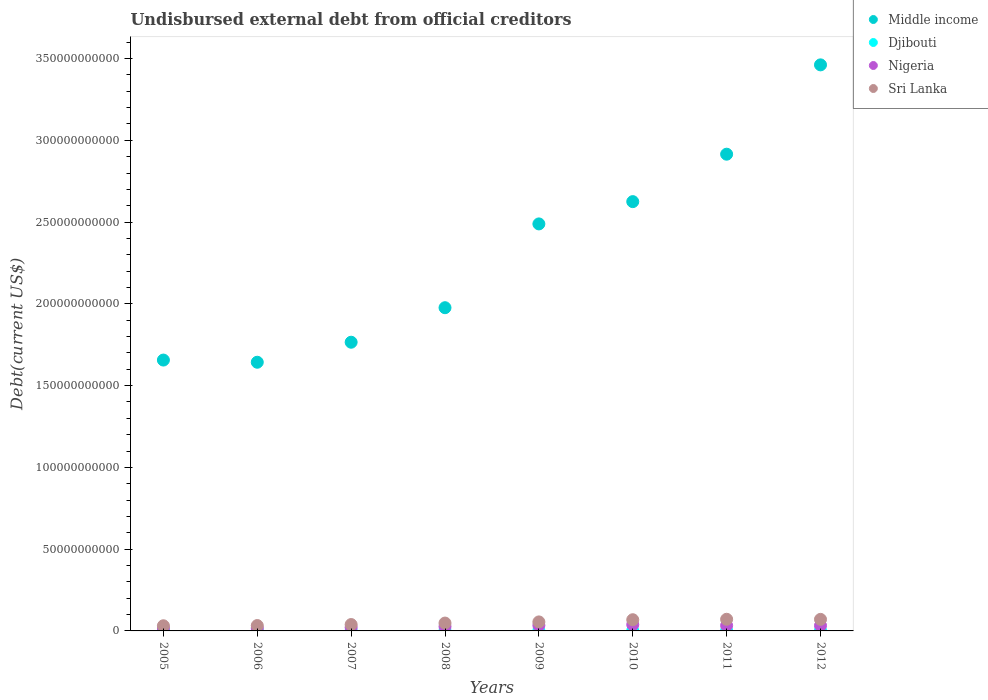What is the total debt in Nigeria in 2012?
Give a very brief answer. 3.26e+09. Across all years, what is the maximum total debt in Nigeria?
Make the answer very short. 3.84e+09. Across all years, what is the minimum total debt in Nigeria?
Ensure brevity in your answer.  1.75e+09. In which year was the total debt in Sri Lanka maximum?
Your response must be concise. 2011. In which year was the total debt in Sri Lanka minimum?
Ensure brevity in your answer.  2005. What is the total total debt in Djibouti in the graph?
Keep it short and to the point. 1.71e+09. What is the difference between the total debt in Nigeria in 2011 and that in 2012?
Make the answer very short. 2.67e+07. What is the difference between the total debt in Middle income in 2011 and the total debt in Sri Lanka in 2009?
Ensure brevity in your answer.  2.86e+11. What is the average total debt in Middle income per year?
Offer a very short reply. 2.32e+11. In the year 2006, what is the difference between the total debt in Djibouti and total debt in Sri Lanka?
Your answer should be very brief. -3.05e+09. What is the ratio of the total debt in Sri Lanka in 2007 to that in 2012?
Your response must be concise. 0.55. Is the difference between the total debt in Djibouti in 2008 and 2010 greater than the difference between the total debt in Sri Lanka in 2008 and 2010?
Provide a short and direct response. Yes. What is the difference between the highest and the second highest total debt in Middle income?
Offer a very short reply. 5.46e+1. What is the difference between the highest and the lowest total debt in Nigeria?
Offer a terse response. 2.09e+09. Is it the case that in every year, the sum of the total debt in Sri Lanka and total debt in Middle income  is greater than the total debt in Nigeria?
Provide a short and direct response. Yes. Does the total debt in Djibouti monotonically increase over the years?
Keep it short and to the point. No. How many dotlines are there?
Ensure brevity in your answer.  4. What is the difference between two consecutive major ticks on the Y-axis?
Provide a short and direct response. 5.00e+1. Does the graph contain grids?
Your response must be concise. No. Where does the legend appear in the graph?
Offer a terse response. Top right. What is the title of the graph?
Make the answer very short. Undisbursed external debt from official creditors. What is the label or title of the X-axis?
Give a very brief answer. Years. What is the label or title of the Y-axis?
Your answer should be compact. Debt(current US$). What is the Debt(current US$) in Middle income in 2005?
Your response must be concise. 1.66e+11. What is the Debt(current US$) of Djibouti in 2005?
Your answer should be compact. 2.41e+08. What is the Debt(current US$) of Nigeria in 2005?
Keep it short and to the point. 1.79e+09. What is the Debt(current US$) in Sri Lanka in 2005?
Ensure brevity in your answer.  3.15e+09. What is the Debt(current US$) in Middle income in 2006?
Provide a succinct answer. 1.64e+11. What is the Debt(current US$) in Djibouti in 2006?
Keep it short and to the point. 2.34e+08. What is the Debt(current US$) in Nigeria in 2006?
Make the answer very short. 1.75e+09. What is the Debt(current US$) of Sri Lanka in 2006?
Make the answer very short. 3.29e+09. What is the Debt(current US$) in Middle income in 2007?
Give a very brief answer. 1.77e+11. What is the Debt(current US$) of Djibouti in 2007?
Your response must be concise. 2.20e+08. What is the Debt(current US$) of Nigeria in 2007?
Your answer should be compact. 2.13e+09. What is the Debt(current US$) of Sri Lanka in 2007?
Keep it short and to the point. 3.90e+09. What is the Debt(current US$) of Middle income in 2008?
Your answer should be compact. 1.98e+11. What is the Debt(current US$) in Djibouti in 2008?
Your answer should be very brief. 2.08e+08. What is the Debt(current US$) of Nigeria in 2008?
Offer a terse response. 2.69e+09. What is the Debt(current US$) in Sri Lanka in 2008?
Keep it short and to the point. 4.80e+09. What is the Debt(current US$) of Middle income in 2009?
Make the answer very short. 2.49e+11. What is the Debt(current US$) of Djibouti in 2009?
Your answer should be compact. 1.66e+08. What is the Debt(current US$) in Nigeria in 2009?
Your answer should be very brief. 3.40e+09. What is the Debt(current US$) in Sri Lanka in 2009?
Your answer should be compact. 5.51e+09. What is the Debt(current US$) of Middle income in 2010?
Provide a short and direct response. 2.63e+11. What is the Debt(current US$) of Djibouti in 2010?
Make the answer very short. 1.83e+08. What is the Debt(current US$) of Nigeria in 2010?
Your response must be concise. 3.84e+09. What is the Debt(current US$) of Sri Lanka in 2010?
Provide a short and direct response. 6.85e+09. What is the Debt(current US$) of Middle income in 2011?
Your answer should be very brief. 2.92e+11. What is the Debt(current US$) in Djibouti in 2011?
Make the answer very short. 1.73e+08. What is the Debt(current US$) of Nigeria in 2011?
Offer a very short reply. 3.29e+09. What is the Debt(current US$) of Sri Lanka in 2011?
Provide a succinct answer. 7.13e+09. What is the Debt(current US$) of Middle income in 2012?
Ensure brevity in your answer.  3.46e+11. What is the Debt(current US$) in Djibouti in 2012?
Your response must be concise. 2.85e+08. What is the Debt(current US$) in Nigeria in 2012?
Your response must be concise. 3.26e+09. What is the Debt(current US$) in Sri Lanka in 2012?
Make the answer very short. 7.06e+09. Across all years, what is the maximum Debt(current US$) in Middle income?
Offer a very short reply. 3.46e+11. Across all years, what is the maximum Debt(current US$) of Djibouti?
Provide a short and direct response. 2.85e+08. Across all years, what is the maximum Debt(current US$) in Nigeria?
Keep it short and to the point. 3.84e+09. Across all years, what is the maximum Debt(current US$) of Sri Lanka?
Give a very brief answer. 7.13e+09. Across all years, what is the minimum Debt(current US$) in Middle income?
Offer a very short reply. 1.64e+11. Across all years, what is the minimum Debt(current US$) in Djibouti?
Your answer should be compact. 1.66e+08. Across all years, what is the minimum Debt(current US$) in Nigeria?
Provide a succinct answer. 1.75e+09. Across all years, what is the minimum Debt(current US$) in Sri Lanka?
Offer a very short reply. 3.15e+09. What is the total Debt(current US$) of Middle income in the graph?
Give a very brief answer. 1.85e+12. What is the total Debt(current US$) in Djibouti in the graph?
Give a very brief answer. 1.71e+09. What is the total Debt(current US$) of Nigeria in the graph?
Offer a very short reply. 2.22e+1. What is the total Debt(current US$) of Sri Lanka in the graph?
Your answer should be very brief. 4.17e+1. What is the difference between the Debt(current US$) in Middle income in 2005 and that in 2006?
Offer a very short reply. 1.33e+09. What is the difference between the Debt(current US$) in Djibouti in 2005 and that in 2006?
Keep it short and to the point. 7.64e+06. What is the difference between the Debt(current US$) in Nigeria in 2005 and that in 2006?
Ensure brevity in your answer.  3.52e+07. What is the difference between the Debt(current US$) in Sri Lanka in 2005 and that in 2006?
Make the answer very short. -1.40e+08. What is the difference between the Debt(current US$) of Middle income in 2005 and that in 2007?
Make the answer very short. -1.09e+1. What is the difference between the Debt(current US$) of Djibouti in 2005 and that in 2007?
Provide a succinct answer. 2.10e+07. What is the difference between the Debt(current US$) in Nigeria in 2005 and that in 2007?
Provide a succinct answer. -3.43e+08. What is the difference between the Debt(current US$) in Sri Lanka in 2005 and that in 2007?
Your answer should be compact. -7.50e+08. What is the difference between the Debt(current US$) in Middle income in 2005 and that in 2008?
Keep it short and to the point. -3.20e+1. What is the difference between the Debt(current US$) of Djibouti in 2005 and that in 2008?
Make the answer very short. 3.35e+07. What is the difference between the Debt(current US$) in Nigeria in 2005 and that in 2008?
Give a very brief answer. -9.03e+08. What is the difference between the Debt(current US$) of Sri Lanka in 2005 and that in 2008?
Ensure brevity in your answer.  -1.65e+09. What is the difference between the Debt(current US$) in Middle income in 2005 and that in 2009?
Offer a terse response. -8.33e+1. What is the difference between the Debt(current US$) in Djibouti in 2005 and that in 2009?
Make the answer very short. 7.49e+07. What is the difference between the Debt(current US$) in Nigeria in 2005 and that in 2009?
Your answer should be compact. -1.62e+09. What is the difference between the Debt(current US$) of Sri Lanka in 2005 and that in 2009?
Your response must be concise. -2.36e+09. What is the difference between the Debt(current US$) of Middle income in 2005 and that in 2010?
Provide a succinct answer. -9.69e+1. What is the difference between the Debt(current US$) in Djibouti in 2005 and that in 2010?
Keep it short and to the point. 5.84e+07. What is the difference between the Debt(current US$) in Nigeria in 2005 and that in 2010?
Your answer should be very brief. -2.06e+09. What is the difference between the Debt(current US$) in Sri Lanka in 2005 and that in 2010?
Keep it short and to the point. -3.70e+09. What is the difference between the Debt(current US$) of Middle income in 2005 and that in 2011?
Ensure brevity in your answer.  -1.26e+11. What is the difference between the Debt(current US$) in Djibouti in 2005 and that in 2011?
Offer a very short reply. 6.77e+07. What is the difference between the Debt(current US$) in Nigeria in 2005 and that in 2011?
Your answer should be very brief. -1.50e+09. What is the difference between the Debt(current US$) in Sri Lanka in 2005 and that in 2011?
Your answer should be very brief. -3.98e+09. What is the difference between the Debt(current US$) in Middle income in 2005 and that in 2012?
Offer a terse response. -1.81e+11. What is the difference between the Debt(current US$) of Djibouti in 2005 and that in 2012?
Your response must be concise. -4.38e+07. What is the difference between the Debt(current US$) in Nigeria in 2005 and that in 2012?
Offer a terse response. -1.47e+09. What is the difference between the Debt(current US$) in Sri Lanka in 2005 and that in 2012?
Your answer should be compact. -3.91e+09. What is the difference between the Debt(current US$) of Middle income in 2006 and that in 2007?
Your answer should be compact. -1.22e+1. What is the difference between the Debt(current US$) of Djibouti in 2006 and that in 2007?
Keep it short and to the point. 1.34e+07. What is the difference between the Debt(current US$) in Nigeria in 2006 and that in 2007?
Your response must be concise. -3.78e+08. What is the difference between the Debt(current US$) of Sri Lanka in 2006 and that in 2007?
Provide a succinct answer. -6.10e+08. What is the difference between the Debt(current US$) in Middle income in 2006 and that in 2008?
Your response must be concise. -3.34e+1. What is the difference between the Debt(current US$) in Djibouti in 2006 and that in 2008?
Provide a succinct answer. 2.58e+07. What is the difference between the Debt(current US$) in Nigeria in 2006 and that in 2008?
Your answer should be very brief. -9.38e+08. What is the difference between the Debt(current US$) of Sri Lanka in 2006 and that in 2008?
Your answer should be very brief. -1.51e+09. What is the difference between the Debt(current US$) of Middle income in 2006 and that in 2009?
Offer a very short reply. -8.46e+1. What is the difference between the Debt(current US$) of Djibouti in 2006 and that in 2009?
Ensure brevity in your answer.  6.73e+07. What is the difference between the Debt(current US$) in Nigeria in 2006 and that in 2009?
Your answer should be compact. -1.65e+09. What is the difference between the Debt(current US$) in Sri Lanka in 2006 and that in 2009?
Make the answer very short. -2.22e+09. What is the difference between the Debt(current US$) of Middle income in 2006 and that in 2010?
Offer a terse response. -9.82e+1. What is the difference between the Debt(current US$) in Djibouti in 2006 and that in 2010?
Make the answer very short. 5.07e+07. What is the difference between the Debt(current US$) in Nigeria in 2006 and that in 2010?
Give a very brief answer. -2.09e+09. What is the difference between the Debt(current US$) of Sri Lanka in 2006 and that in 2010?
Your answer should be very brief. -3.56e+09. What is the difference between the Debt(current US$) of Middle income in 2006 and that in 2011?
Your answer should be very brief. -1.27e+11. What is the difference between the Debt(current US$) in Djibouti in 2006 and that in 2011?
Offer a very short reply. 6.00e+07. What is the difference between the Debt(current US$) in Nigeria in 2006 and that in 2011?
Your answer should be very brief. -1.53e+09. What is the difference between the Debt(current US$) of Sri Lanka in 2006 and that in 2011?
Offer a terse response. -3.84e+09. What is the difference between the Debt(current US$) of Middle income in 2006 and that in 2012?
Give a very brief answer. -1.82e+11. What is the difference between the Debt(current US$) in Djibouti in 2006 and that in 2012?
Your answer should be very brief. -5.14e+07. What is the difference between the Debt(current US$) of Nigeria in 2006 and that in 2012?
Your answer should be very brief. -1.51e+09. What is the difference between the Debt(current US$) in Sri Lanka in 2006 and that in 2012?
Keep it short and to the point. -3.77e+09. What is the difference between the Debt(current US$) in Middle income in 2007 and that in 2008?
Provide a short and direct response. -2.11e+1. What is the difference between the Debt(current US$) in Djibouti in 2007 and that in 2008?
Your answer should be very brief. 1.25e+07. What is the difference between the Debt(current US$) in Nigeria in 2007 and that in 2008?
Provide a short and direct response. -5.60e+08. What is the difference between the Debt(current US$) in Sri Lanka in 2007 and that in 2008?
Your answer should be very brief. -9.03e+08. What is the difference between the Debt(current US$) in Middle income in 2007 and that in 2009?
Offer a terse response. -7.24e+1. What is the difference between the Debt(current US$) in Djibouti in 2007 and that in 2009?
Offer a terse response. 5.39e+07. What is the difference between the Debt(current US$) in Nigeria in 2007 and that in 2009?
Give a very brief answer. -1.27e+09. What is the difference between the Debt(current US$) of Sri Lanka in 2007 and that in 2009?
Provide a succinct answer. -1.61e+09. What is the difference between the Debt(current US$) in Middle income in 2007 and that in 2010?
Provide a succinct answer. -8.60e+1. What is the difference between the Debt(current US$) of Djibouti in 2007 and that in 2010?
Keep it short and to the point. 3.73e+07. What is the difference between the Debt(current US$) in Nigeria in 2007 and that in 2010?
Provide a succinct answer. -1.71e+09. What is the difference between the Debt(current US$) of Sri Lanka in 2007 and that in 2010?
Provide a short and direct response. -2.95e+09. What is the difference between the Debt(current US$) of Middle income in 2007 and that in 2011?
Keep it short and to the point. -1.15e+11. What is the difference between the Debt(current US$) of Djibouti in 2007 and that in 2011?
Your answer should be compact. 4.67e+07. What is the difference between the Debt(current US$) in Nigeria in 2007 and that in 2011?
Give a very brief answer. -1.16e+09. What is the difference between the Debt(current US$) in Sri Lanka in 2007 and that in 2011?
Provide a short and direct response. -3.23e+09. What is the difference between the Debt(current US$) of Middle income in 2007 and that in 2012?
Offer a very short reply. -1.70e+11. What is the difference between the Debt(current US$) of Djibouti in 2007 and that in 2012?
Give a very brief answer. -6.48e+07. What is the difference between the Debt(current US$) of Nigeria in 2007 and that in 2012?
Your answer should be very brief. -1.13e+09. What is the difference between the Debt(current US$) of Sri Lanka in 2007 and that in 2012?
Make the answer very short. -3.16e+09. What is the difference between the Debt(current US$) in Middle income in 2008 and that in 2009?
Make the answer very short. -5.12e+1. What is the difference between the Debt(current US$) in Djibouti in 2008 and that in 2009?
Provide a short and direct response. 4.14e+07. What is the difference between the Debt(current US$) in Nigeria in 2008 and that in 2009?
Keep it short and to the point. -7.13e+08. What is the difference between the Debt(current US$) of Sri Lanka in 2008 and that in 2009?
Your answer should be compact. -7.10e+08. What is the difference between the Debt(current US$) in Middle income in 2008 and that in 2010?
Offer a very short reply. -6.49e+1. What is the difference between the Debt(current US$) of Djibouti in 2008 and that in 2010?
Ensure brevity in your answer.  2.49e+07. What is the difference between the Debt(current US$) in Nigeria in 2008 and that in 2010?
Your answer should be compact. -1.15e+09. What is the difference between the Debt(current US$) of Sri Lanka in 2008 and that in 2010?
Give a very brief answer. -2.04e+09. What is the difference between the Debt(current US$) in Middle income in 2008 and that in 2011?
Keep it short and to the point. -9.39e+1. What is the difference between the Debt(current US$) in Djibouti in 2008 and that in 2011?
Keep it short and to the point. 3.42e+07. What is the difference between the Debt(current US$) of Nigeria in 2008 and that in 2011?
Keep it short and to the point. -5.95e+08. What is the difference between the Debt(current US$) in Sri Lanka in 2008 and that in 2011?
Keep it short and to the point. -2.32e+09. What is the difference between the Debt(current US$) of Middle income in 2008 and that in 2012?
Your answer should be compact. -1.49e+11. What is the difference between the Debt(current US$) of Djibouti in 2008 and that in 2012?
Provide a short and direct response. -7.73e+07. What is the difference between the Debt(current US$) in Nigeria in 2008 and that in 2012?
Make the answer very short. -5.69e+08. What is the difference between the Debt(current US$) in Sri Lanka in 2008 and that in 2012?
Your response must be concise. -2.26e+09. What is the difference between the Debt(current US$) in Middle income in 2009 and that in 2010?
Make the answer very short. -1.36e+1. What is the difference between the Debt(current US$) of Djibouti in 2009 and that in 2010?
Your answer should be compact. -1.66e+07. What is the difference between the Debt(current US$) in Nigeria in 2009 and that in 2010?
Offer a very short reply. -4.40e+08. What is the difference between the Debt(current US$) of Sri Lanka in 2009 and that in 2010?
Provide a succinct answer. -1.33e+09. What is the difference between the Debt(current US$) in Middle income in 2009 and that in 2011?
Offer a very short reply. -4.26e+1. What is the difference between the Debt(current US$) of Djibouti in 2009 and that in 2011?
Offer a terse response. -7.25e+06. What is the difference between the Debt(current US$) of Nigeria in 2009 and that in 2011?
Make the answer very short. 1.18e+08. What is the difference between the Debt(current US$) of Sri Lanka in 2009 and that in 2011?
Offer a very short reply. -1.61e+09. What is the difference between the Debt(current US$) in Middle income in 2009 and that in 2012?
Your response must be concise. -9.73e+1. What is the difference between the Debt(current US$) of Djibouti in 2009 and that in 2012?
Your answer should be compact. -1.19e+08. What is the difference between the Debt(current US$) of Nigeria in 2009 and that in 2012?
Provide a succinct answer. 1.45e+08. What is the difference between the Debt(current US$) in Sri Lanka in 2009 and that in 2012?
Provide a short and direct response. -1.55e+09. What is the difference between the Debt(current US$) in Middle income in 2010 and that in 2011?
Your answer should be very brief. -2.90e+1. What is the difference between the Debt(current US$) of Djibouti in 2010 and that in 2011?
Provide a short and direct response. 9.31e+06. What is the difference between the Debt(current US$) of Nigeria in 2010 and that in 2011?
Your answer should be compact. 5.58e+08. What is the difference between the Debt(current US$) in Sri Lanka in 2010 and that in 2011?
Ensure brevity in your answer.  -2.80e+08. What is the difference between the Debt(current US$) of Middle income in 2010 and that in 2012?
Your answer should be very brief. -8.36e+1. What is the difference between the Debt(current US$) of Djibouti in 2010 and that in 2012?
Your answer should be compact. -1.02e+08. What is the difference between the Debt(current US$) in Nigeria in 2010 and that in 2012?
Your answer should be compact. 5.84e+08. What is the difference between the Debt(current US$) in Sri Lanka in 2010 and that in 2012?
Keep it short and to the point. -2.14e+08. What is the difference between the Debt(current US$) in Middle income in 2011 and that in 2012?
Your response must be concise. -5.46e+1. What is the difference between the Debt(current US$) in Djibouti in 2011 and that in 2012?
Ensure brevity in your answer.  -1.11e+08. What is the difference between the Debt(current US$) in Nigeria in 2011 and that in 2012?
Give a very brief answer. 2.67e+07. What is the difference between the Debt(current US$) in Sri Lanka in 2011 and that in 2012?
Make the answer very short. 6.60e+07. What is the difference between the Debt(current US$) in Middle income in 2005 and the Debt(current US$) in Djibouti in 2006?
Your answer should be compact. 1.65e+11. What is the difference between the Debt(current US$) in Middle income in 2005 and the Debt(current US$) in Nigeria in 2006?
Make the answer very short. 1.64e+11. What is the difference between the Debt(current US$) of Middle income in 2005 and the Debt(current US$) of Sri Lanka in 2006?
Give a very brief answer. 1.62e+11. What is the difference between the Debt(current US$) in Djibouti in 2005 and the Debt(current US$) in Nigeria in 2006?
Keep it short and to the point. -1.51e+09. What is the difference between the Debt(current US$) in Djibouti in 2005 and the Debt(current US$) in Sri Lanka in 2006?
Ensure brevity in your answer.  -3.05e+09. What is the difference between the Debt(current US$) of Nigeria in 2005 and the Debt(current US$) of Sri Lanka in 2006?
Your answer should be very brief. -1.50e+09. What is the difference between the Debt(current US$) of Middle income in 2005 and the Debt(current US$) of Djibouti in 2007?
Your response must be concise. 1.65e+11. What is the difference between the Debt(current US$) of Middle income in 2005 and the Debt(current US$) of Nigeria in 2007?
Offer a terse response. 1.64e+11. What is the difference between the Debt(current US$) of Middle income in 2005 and the Debt(current US$) of Sri Lanka in 2007?
Your answer should be compact. 1.62e+11. What is the difference between the Debt(current US$) in Djibouti in 2005 and the Debt(current US$) in Nigeria in 2007?
Your answer should be compact. -1.89e+09. What is the difference between the Debt(current US$) of Djibouti in 2005 and the Debt(current US$) of Sri Lanka in 2007?
Ensure brevity in your answer.  -3.66e+09. What is the difference between the Debt(current US$) of Nigeria in 2005 and the Debt(current US$) of Sri Lanka in 2007?
Give a very brief answer. -2.11e+09. What is the difference between the Debt(current US$) of Middle income in 2005 and the Debt(current US$) of Djibouti in 2008?
Ensure brevity in your answer.  1.65e+11. What is the difference between the Debt(current US$) in Middle income in 2005 and the Debt(current US$) in Nigeria in 2008?
Give a very brief answer. 1.63e+11. What is the difference between the Debt(current US$) in Middle income in 2005 and the Debt(current US$) in Sri Lanka in 2008?
Make the answer very short. 1.61e+11. What is the difference between the Debt(current US$) of Djibouti in 2005 and the Debt(current US$) of Nigeria in 2008?
Offer a very short reply. -2.45e+09. What is the difference between the Debt(current US$) of Djibouti in 2005 and the Debt(current US$) of Sri Lanka in 2008?
Your answer should be very brief. -4.56e+09. What is the difference between the Debt(current US$) of Nigeria in 2005 and the Debt(current US$) of Sri Lanka in 2008?
Ensure brevity in your answer.  -3.01e+09. What is the difference between the Debt(current US$) of Middle income in 2005 and the Debt(current US$) of Djibouti in 2009?
Offer a terse response. 1.65e+11. What is the difference between the Debt(current US$) of Middle income in 2005 and the Debt(current US$) of Nigeria in 2009?
Ensure brevity in your answer.  1.62e+11. What is the difference between the Debt(current US$) in Middle income in 2005 and the Debt(current US$) in Sri Lanka in 2009?
Your answer should be very brief. 1.60e+11. What is the difference between the Debt(current US$) of Djibouti in 2005 and the Debt(current US$) of Nigeria in 2009?
Your answer should be compact. -3.16e+09. What is the difference between the Debt(current US$) in Djibouti in 2005 and the Debt(current US$) in Sri Lanka in 2009?
Provide a short and direct response. -5.27e+09. What is the difference between the Debt(current US$) in Nigeria in 2005 and the Debt(current US$) in Sri Lanka in 2009?
Provide a succinct answer. -3.72e+09. What is the difference between the Debt(current US$) in Middle income in 2005 and the Debt(current US$) in Djibouti in 2010?
Provide a short and direct response. 1.65e+11. What is the difference between the Debt(current US$) of Middle income in 2005 and the Debt(current US$) of Nigeria in 2010?
Your answer should be very brief. 1.62e+11. What is the difference between the Debt(current US$) of Middle income in 2005 and the Debt(current US$) of Sri Lanka in 2010?
Your answer should be compact. 1.59e+11. What is the difference between the Debt(current US$) in Djibouti in 2005 and the Debt(current US$) in Nigeria in 2010?
Provide a succinct answer. -3.60e+09. What is the difference between the Debt(current US$) of Djibouti in 2005 and the Debt(current US$) of Sri Lanka in 2010?
Provide a succinct answer. -6.60e+09. What is the difference between the Debt(current US$) of Nigeria in 2005 and the Debt(current US$) of Sri Lanka in 2010?
Your response must be concise. -5.06e+09. What is the difference between the Debt(current US$) in Middle income in 2005 and the Debt(current US$) in Djibouti in 2011?
Your answer should be compact. 1.65e+11. What is the difference between the Debt(current US$) in Middle income in 2005 and the Debt(current US$) in Nigeria in 2011?
Ensure brevity in your answer.  1.62e+11. What is the difference between the Debt(current US$) of Middle income in 2005 and the Debt(current US$) of Sri Lanka in 2011?
Ensure brevity in your answer.  1.59e+11. What is the difference between the Debt(current US$) of Djibouti in 2005 and the Debt(current US$) of Nigeria in 2011?
Your answer should be very brief. -3.05e+09. What is the difference between the Debt(current US$) in Djibouti in 2005 and the Debt(current US$) in Sri Lanka in 2011?
Provide a succinct answer. -6.88e+09. What is the difference between the Debt(current US$) in Nigeria in 2005 and the Debt(current US$) in Sri Lanka in 2011?
Provide a short and direct response. -5.34e+09. What is the difference between the Debt(current US$) in Middle income in 2005 and the Debt(current US$) in Djibouti in 2012?
Provide a succinct answer. 1.65e+11. What is the difference between the Debt(current US$) of Middle income in 2005 and the Debt(current US$) of Nigeria in 2012?
Make the answer very short. 1.62e+11. What is the difference between the Debt(current US$) of Middle income in 2005 and the Debt(current US$) of Sri Lanka in 2012?
Offer a very short reply. 1.59e+11. What is the difference between the Debt(current US$) of Djibouti in 2005 and the Debt(current US$) of Nigeria in 2012?
Keep it short and to the point. -3.02e+09. What is the difference between the Debt(current US$) of Djibouti in 2005 and the Debt(current US$) of Sri Lanka in 2012?
Offer a terse response. -6.82e+09. What is the difference between the Debt(current US$) in Nigeria in 2005 and the Debt(current US$) in Sri Lanka in 2012?
Offer a very short reply. -5.27e+09. What is the difference between the Debt(current US$) of Middle income in 2006 and the Debt(current US$) of Djibouti in 2007?
Make the answer very short. 1.64e+11. What is the difference between the Debt(current US$) in Middle income in 2006 and the Debt(current US$) in Nigeria in 2007?
Keep it short and to the point. 1.62e+11. What is the difference between the Debt(current US$) of Middle income in 2006 and the Debt(current US$) of Sri Lanka in 2007?
Provide a short and direct response. 1.60e+11. What is the difference between the Debt(current US$) in Djibouti in 2006 and the Debt(current US$) in Nigeria in 2007?
Keep it short and to the point. -1.90e+09. What is the difference between the Debt(current US$) of Djibouti in 2006 and the Debt(current US$) of Sri Lanka in 2007?
Offer a terse response. -3.67e+09. What is the difference between the Debt(current US$) of Nigeria in 2006 and the Debt(current US$) of Sri Lanka in 2007?
Ensure brevity in your answer.  -2.15e+09. What is the difference between the Debt(current US$) of Middle income in 2006 and the Debt(current US$) of Djibouti in 2008?
Offer a terse response. 1.64e+11. What is the difference between the Debt(current US$) in Middle income in 2006 and the Debt(current US$) in Nigeria in 2008?
Keep it short and to the point. 1.62e+11. What is the difference between the Debt(current US$) of Middle income in 2006 and the Debt(current US$) of Sri Lanka in 2008?
Your response must be concise. 1.60e+11. What is the difference between the Debt(current US$) in Djibouti in 2006 and the Debt(current US$) in Nigeria in 2008?
Make the answer very short. -2.46e+09. What is the difference between the Debt(current US$) in Djibouti in 2006 and the Debt(current US$) in Sri Lanka in 2008?
Give a very brief answer. -4.57e+09. What is the difference between the Debt(current US$) of Nigeria in 2006 and the Debt(current US$) of Sri Lanka in 2008?
Make the answer very short. -3.05e+09. What is the difference between the Debt(current US$) of Middle income in 2006 and the Debt(current US$) of Djibouti in 2009?
Your answer should be very brief. 1.64e+11. What is the difference between the Debt(current US$) of Middle income in 2006 and the Debt(current US$) of Nigeria in 2009?
Your response must be concise. 1.61e+11. What is the difference between the Debt(current US$) of Middle income in 2006 and the Debt(current US$) of Sri Lanka in 2009?
Your answer should be very brief. 1.59e+11. What is the difference between the Debt(current US$) of Djibouti in 2006 and the Debt(current US$) of Nigeria in 2009?
Your response must be concise. -3.17e+09. What is the difference between the Debt(current US$) of Djibouti in 2006 and the Debt(current US$) of Sri Lanka in 2009?
Your response must be concise. -5.28e+09. What is the difference between the Debt(current US$) in Nigeria in 2006 and the Debt(current US$) in Sri Lanka in 2009?
Keep it short and to the point. -3.76e+09. What is the difference between the Debt(current US$) of Middle income in 2006 and the Debt(current US$) of Djibouti in 2010?
Give a very brief answer. 1.64e+11. What is the difference between the Debt(current US$) in Middle income in 2006 and the Debt(current US$) in Nigeria in 2010?
Make the answer very short. 1.60e+11. What is the difference between the Debt(current US$) of Middle income in 2006 and the Debt(current US$) of Sri Lanka in 2010?
Your response must be concise. 1.57e+11. What is the difference between the Debt(current US$) in Djibouti in 2006 and the Debt(current US$) in Nigeria in 2010?
Give a very brief answer. -3.61e+09. What is the difference between the Debt(current US$) in Djibouti in 2006 and the Debt(current US$) in Sri Lanka in 2010?
Provide a succinct answer. -6.61e+09. What is the difference between the Debt(current US$) of Nigeria in 2006 and the Debt(current US$) of Sri Lanka in 2010?
Your response must be concise. -5.09e+09. What is the difference between the Debt(current US$) in Middle income in 2006 and the Debt(current US$) in Djibouti in 2011?
Provide a succinct answer. 1.64e+11. What is the difference between the Debt(current US$) of Middle income in 2006 and the Debt(current US$) of Nigeria in 2011?
Offer a very short reply. 1.61e+11. What is the difference between the Debt(current US$) of Middle income in 2006 and the Debt(current US$) of Sri Lanka in 2011?
Keep it short and to the point. 1.57e+11. What is the difference between the Debt(current US$) in Djibouti in 2006 and the Debt(current US$) in Nigeria in 2011?
Make the answer very short. -3.05e+09. What is the difference between the Debt(current US$) of Djibouti in 2006 and the Debt(current US$) of Sri Lanka in 2011?
Provide a succinct answer. -6.89e+09. What is the difference between the Debt(current US$) of Nigeria in 2006 and the Debt(current US$) of Sri Lanka in 2011?
Keep it short and to the point. -5.37e+09. What is the difference between the Debt(current US$) of Middle income in 2006 and the Debt(current US$) of Djibouti in 2012?
Your response must be concise. 1.64e+11. What is the difference between the Debt(current US$) in Middle income in 2006 and the Debt(current US$) in Nigeria in 2012?
Keep it short and to the point. 1.61e+11. What is the difference between the Debt(current US$) in Middle income in 2006 and the Debt(current US$) in Sri Lanka in 2012?
Ensure brevity in your answer.  1.57e+11. What is the difference between the Debt(current US$) in Djibouti in 2006 and the Debt(current US$) in Nigeria in 2012?
Your answer should be compact. -3.03e+09. What is the difference between the Debt(current US$) in Djibouti in 2006 and the Debt(current US$) in Sri Lanka in 2012?
Provide a succinct answer. -6.83e+09. What is the difference between the Debt(current US$) in Nigeria in 2006 and the Debt(current US$) in Sri Lanka in 2012?
Keep it short and to the point. -5.31e+09. What is the difference between the Debt(current US$) of Middle income in 2007 and the Debt(current US$) of Djibouti in 2008?
Provide a short and direct response. 1.76e+11. What is the difference between the Debt(current US$) of Middle income in 2007 and the Debt(current US$) of Nigeria in 2008?
Your response must be concise. 1.74e+11. What is the difference between the Debt(current US$) of Middle income in 2007 and the Debt(current US$) of Sri Lanka in 2008?
Provide a short and direct response. 1.72e+11. What is the difference between the Debt(current US$) in Djibouti in 2007 and the Debt(current US$) in Nigeria in 2008?
Your answer should be very brief. -2.47e+09. What is the difference between the Debt(current US$) of Djibouti in 2007 and the Debt(current US$) of Sri Lanka in 2008?
Your response must be concise. -4.58e+09. What is the difference between the Debt(current US$) of Nigeria in 2007 and the Debt(current US$) of Sri Lanka in 2008?
Give a very brief answer. -2.67e+09. What is the difference between the Debt(current US$) in Middle income in 2007 and the Debt(current US$) in Djibouti in 2009?
Offer a terse response. 1.76e+11. What is the difference between the Debt(current US$) in Middle income in 2007 and the Debt(current US$) in Nigeria in 2009?
Make the answer very short. 1.73e+11. What is the difference between the Debt(current US$) of Middle income in 2007 and the Debt(current US$) of Sri Lanka in 2009?
Make the answer very short. 1.71e+11. What is the difference between the Debt(current US$) of Djibouti in 2007 and the Debt(current US$) of Nigeria in 2009?
Your answer should be compact. -3.18e+09. What is the difference between the Debt(current US$) in Djibouti in 2007 and the Debt(current US$) in Sri Lanka in 2009?
Provide a succinct answer. -5.29e+09. What is the difference between the Debt(current US$) in Nigeria in 2007 and the Debt(current US$) in Sri Lanka in 2009?
Your answer should be very brief. -3.38e+09. What is the difference between the Debt(current US$) of Middle income in 2007 and the Debt(current US$) of Djibouti in 2010?
Your answer should be very brief. 1.76e+11. What is the difference between the Debt(current US$) of Middle income in 2007 and the Debt(current US$) of Nigeria in 2010?
Keep it short and to the point. 1.73e+11. What is the difference between the Debt(current US$) in Middle income in 2007 and the Debt(current US$) in Sri Lanka in 2010?
Your answer should be very brief. 1.70e+11. What is the difference between the Debt(current US$) of Djibouti in 2007 and the Debt(current US$) of Nigeria in 2010?
Make the answer very short. -3.62e+09. What is the difference between the Debt(current US$) in Djibouti in 2007 and the Debt(current US$) in Sri Lanka in 2010?
Give a very brief answer. -6.63e+09. What is the difference between the Debt(current US$) in Nigeria in 2007 and the Debt(current US$) in Sri Lanka in 2010?
Your response must be concise. -4.71e+09. What is the difference between the Debt(current US$) in Middle income in 2007 and the Debt(current US$) in Djibouti in 2011?
Keep it short and to the point. 1.76e+11. What is the difference between the Debt(current US$) in Middle income in 2007 and the Debt(current US$) in Nigeria in 2011?
Offer a very short reply. 1.73e+11. What is the difference between the Debt(current US$) in Middle income in 2007 and the Debt(current US$) in Sri Lanka in 2011?
Your response must be concise. 1.69e+11. What is the difference between the Debt(current US$) of Djibouti in 2007 and the Debt(current US$) of Nigeria in 2011?
Provide a short and direct response. -3.07e+09. What is the difference between the Debt(current US$) of Djibouti in 2007 and the Debt(current US$) of Sri Lanka in 2011?
Your answer should be compact. -6.91e+09. What is the difference between the Debt(current US$) of Nigeria in 2007 and the Debt(current US$) of Sri Lanka in 2011?
Keep it short and to the point. -5.00e+09. What is the difference between the Debt(current US$) in Middle income in 2007 and the Debt(current US$) in Djibouti in 2012?
Offer a terse response. 1.76e+11. What is the difference between the Debt(current US$) of Middle income in 2007 and the Debt(current US$) of Nigeria in 2012?
Your answer should be very brief. 1.73e+11. What is the difference between the Debt(current US$) of Middle income in 2007 and the Debt(current US$) of Sri Lanka in 2012?
Keep it short and to the point. 1.69e+11. What is the difference between the Debt(current US$) in Djibouti in 2007 and the Debt(current US$) in Nigeria in 2012?
Ensure brevity in your answer.  -3.04e+09. What is the difference between the Debt(current US$) in Djibouti in 2007 and the Debt(current US$) in Sri Lanka in 2012?
Ensure brevity in your answer.  -6.84e+09. What is the difference between the Debt(current US$) of Nigeria in 2007 and the Debt(current US$) of Sri Lanka in 2012?
Give a very brief answer. -4.93e+09. What is the difference between the Debt(current US$) of Middle income in 2008 and the Debt(current US$) of Djibouti in 2009?
Ensure brevity in your answer.  1.97e+11. What is the difference between the Debt(current US$) of Middle income in 2008 and the Debt(current US$) of Nigeria in 2009?
Provide a succinct answer. 1.94e+11. What is the difference between the Debt(current US$) of Middle income in 2008 and the Debt(current US$) of Sri Lanka in 2009?
Offer a very short reply. 1.92e+11. What is the difference between the Debt(current US$) of Djibouti in 2008 and the Debt(current US$) of Nigeria in 2009?
Provide a short and direct response. -3.20e+09. What is the difference between the Debt(current US$) of Djibouti in 2008 and the Debt(current US$) of Sri Lanka in 2009?
Your answer should be compact. -5.30e+09. What is the difference between the Debt(current US$) in Nigeria in 2008 and the Debt(current US$) in Sri Lanka in 2009?
Ensure brevity in your answer.  -2.82e+09. What is the difference between the Debt(current US$) in Middle income in 2008 and the Debt(current US$) in Djibouti in 2010?
Give a very brief answer. 1.97e+11. What is the difference between the Debt(current US$) in Middle income in 2008 and the Debt(current US$) in Nigeria in 2010?
Offer a terse response. 1.94e+11. What is the difference between the Debt(current US$) in Middle income in 2008 and the Debt(current US$) in Sri Lanka in 2010?
Your answer should be very brief. 1.91e+11. What is the difference between the Debt(current US$) in Djibouti in 2008 and the Debt(current US$) in Nigeria in 2010?
Your answer should be very brief. -3.64e+09. What is the difference between the Debt(current US$) of Djibouti in 2008 and the Debt(current US$) of Sri Lanka in 2010?
Offer a very short reply. -6.64e+09. What is the difference between the Debt(current US$) of Nigeria in 2008 and the Debt(current US$) of Sri Lanka in 2010?
Give a very brief answer. -4.15e+09. What is the difference between the Debt(current US$) in Middle income in 2008 and the Debt(current US$) in Djibouti in 2011?
Your response must be concise. 1.97e+11. What is the difference between the Debt(current US$) of Middle income in 2008 and the Debt(current US$) of Nigeria in 2011?
Provide a short and direct response. 1.94e+11. What is the difference between the Debt(current US$) of Middle income in 2008 and the Debt(current US$) of Sri Lanka in 2011?
Ensure brevity in your answer.  1.91e+11. What is the difference between the Debt(current US$) of Djibouti in 2008 and the Debt(current US$) of Nigeria in 2011?
Keep it short and to the point. -3.08e+09. What is the difference between the Debt(current US$) in Djibouti in 2008 and the Debt(current US$) in Sri Lanka in 2011?
Provide a succinct answer. -6.92e+09. What is the difference between the Debt(current US$) in Nigeria in 2008 and the Debt(current US$) in Sri Lanka in 2011?
Your answer should be compact. -4.43e+09. What is the difference between the Debt(current US$) of Middle income in 2008 and the Debt(current US$) of Djibouti in 2012?
Your answer should be compact. 1.97e+11. What is the difference between the Debt(current US$) of Middle income in 2008 and the Debt(current US$) of Nigeria in 2012?
Offer a terse response. 1.94e+11. What is the difference between the Debt(current US$) in Middle income in 2008 and the Debt(current US$) in Sri Lanka in 2012?
Your response must be concise. 1.91e+11. What is the difference between the Debt(current US$) in Djibouti in 2008 and the Debt(current US$) in Nigeria in 2012?
Your answer should be compact. -3.05e+09. What is the difference between the Debt(current US$) in Djibouti in 2008 and the Debt(current US$) in Sri Lanka in 2012?
Offer a very short reply. -6.85e+09. What is the difference between the Debt(current US$) in Nigeria in 2008 and the Debt(current US$) in Sri Lanka in 2012?
Provide a succinct answer. -4.37e+09. What is the difference between the Debt(current US$) in Middle income in 2009 and the Debt(current US$) in Djibouti in 2010?
Provide a short and direct response. 2.49e+11. What is the difference between the Debt(current US$) in Middle income in 2009 and the Debt(current US$) in Nigeria in 2010?
Offer a terse response. 2.45e+11. What is the difference between the Debt(current US$) in Middle income in 2009 and the Debt(current US$) in Sri Lanka in 2010?
Give a very brief answer. 2.42e+11. What is the difference between the Debt(current US$) in Djibouti in 2009 and the Debt(current US$) in Nigeria in 2010?
Ensure brevity in your answer.  -3.68e+09. What is the difference between the Debt(current US$) in Djibouti in 2009 and the Debt(current US$) in Sri Lanka in 2010?
Keep it short and to the point. -6.68e+09. What is the difference between the Debt(current US$) of Nigeria in 2009 and the Debt(current US$) of Sri Lanka in 2010?
Ensure brevity in your answer.  -3.44e+09. What is the difference between the Debt(current US$) in Middle income in 2009 and the Debt(current US$) in Djibouti in 2011?
Ensure brevity in your answer.  2.49e+11. What is the difference between the Debt(current US$) in Middle income in 2009 and the Debt(current US$) in Nigeria in 2011?
Keep it short and to the point. 2.46e+11. What is the difference between the Debt(current US$) in Middle income in 2009 and the Debt(current US$) in Sri Lanka in 2011?
Your answer should be very brief. 2.42e+11. What is the difference between the Debt(current US$) in Djibouti in 2009 and the Debt(current US$) in Nigeria in 2011?
Give a very brief answer. -3.12e+09. What is the difference between the Debt(current US$) of Djibouti in 2009 and the Debt(current US$) of Sri Lanka in 2011?
Keep it short and to the point. -6.96e+09. What is the difference between the Debt(current US$) in Nigeria in 2009 and the Debt(current US$) in Sri Lanka in 2011?
Keep it short and to the point. -3.72e+09. What is the difference between the Debt(current US$) in Middle income in 2009 and the Debt(current US$) in Djibouti in 2012?
Provide a succinct answer. 2.49e+11. What is the difference between the Debt(current US$) in Middle income in 2009 and the Debt(current US$) in Nigeria in 2012?
Your answer should be compact. 2.46e+11. What is the difference between the Debt(current US$) in Middle income in 2009 and the Debt(current US$) in Sri Lanka in 2012?
Your answer should be very brief. 2.42e+11. What is the difference between the Debt(current US$) of Djibouti in 2009 and the Debt(current US$) of Nigeria in 2012?
Your response must be concise. -3.09e+09. What is the difference between the Debt(current US$) in Djibouti in 2009 and the Debt(current US$) in Sri Lanka in 2012?
Offer a terse response. -6.89e+09. What is the difference between the Debt(current US$) in Nigeria in 2009 and the Debt(current US$) in Sri Lanka in 2012?
Offer a terse response. -3.66e+09. What is the difference between the Debt(current US$) in Middle income in 2010 and the Debt(current US$) in Djibouti in 2011?
Your answer should be compact. 2.62e+11. What is the difference between the Debt(current US$) in Middle income in 2010 and the Debt(current US$) in Nigeria in 2011?
Provide a short and direct response. 2.59e+11. What is the difference between the Debt(current US$) in Middle income in 2010 and the Debt(current US$) in Sri Lanka in 2011?
Make the answer very short. 2.55e+11. What is the difference between the Debt(current US$) of Djibouti in 2010 and the Debt(current US$) of Nigeria in 2011?
Your answer should be very brief. -3.10e+09. What is the difference between the Debt(current US$) of Djibouti in 2010 and the Debt(current US$) of Sri Lanka in 2011?
Your response must be concise. -6.94e+09. What is the difference between the Debt(current US$) of Nigeria in 2010 and the Debt(current US$) of Sri Lanka in 2011?
Provide a succinct answer. -3.28e+09. What is the difference between the Debt(current US$) of Middle income in 2010 and the Debt(current US$) of Djibouti in 2012?
Your answer should be very brief. 2.62e+11. What is the difference between the Debt(current US$) in Middle income in 2010 and the Debt(current US$) in Nigeria in 2012?
Provide a short and direct response. 2.59e+11. What is the difference between the Debt(current US$) of Middle income in 2010 and the Debt(current US$) of Sri Lanka in 2012?
Give a very brief answer. 2.55e+11. What is the difference between the Debt(current US$) of Djibouti in 2010 and the Debt(current US$) of Nigeria in 2012?
Your answer should be very brief. -3.08e+09. What is the difference between the Debt(current US$) of Djibouti in 2010 and the Debt(current US$) of Sri Lanka in 2012?
Your answer should be compact. -6.88e+09. What is the difference between the Debt(current US$) in Nigeria in 2010 and the Debt(current US$) in Sri Lanka in 2012?
Provide a succinct answer. -3.22e+09. What is the difference between the Debt(current US$) of Middle income in 2011 and the Debt(current US$) of Djibouti in 2012?
Your answer should be very brief. 2.91e+11. What is the difference between the Debt(current US$) of Middle income in 2011 and the Debt(current US$) of Nigeria in 2012?
Your answer should be compact. 2.88e+11. What is the difference between the Debt(current US$) of Middle income in 2011 and the Debt(current US$) of Sri Lanka in 2012?
Keep it short and to the point. 2.84e+11. What is the difference between the Debt(current US$) of Djibouti in 2011 and the Debt(current US$) of Nigeria in 2012?
Keep it short and to the point. -3.09e+09. What is the difference between the Debt(current US$) of Djibouti in 2011 and the Debt(current US$) of Sri Lanka in 2012?
Offer a very short reply. -6.89e+09. What is the difference between the Debt(current US$) of Nigeria in 2011 and the Debt(current US$) of Sri Lanka in 2012?
Your answer should be very brief. -3.77e+09. What is the average Debt(current US$) in Middle income per year?
Your answer should be very brief. 2.32e+11. What is the average Debt(current US$) in Djibouti per year?
Make the answer very short. 2.14e+08. What is the average Debt(current US$) of Nigeria per year?
Your response must be concise. 2.77e+09. What is the average Debt(current US$) in Sri Lanka per year?
Provide a succinct answer. 5.21e+09. In the year 2005, what is the difference between the Debt(current US$) of Middle income and Debt(current US$) of Djibouti?
Provide a short and direct response. 1.65e+11. In the year 2005, what is the difference between the Debt(current US$) in Middle income and Debt(current US$) in Nigeria?
Offer a terse response. 1.64e+11. In the year 2005, what is the difference between the Debt(current US$) of Middle income and Debt(current US$) of Sri Lanka?
Your answer should be compact. 1.62e+11. In the year 2005, what is the difference between the Debt(current US$) in Djibouti and Debt(current US$) in Nigeria?
Make the answer very short. -1.55e+09. In the year 2005, what is the difference between the Debt(current US$) of Djibouti and Debt(current US$) of Sri Lanka?
Keep it short and to the point. -2.91e+09. In the year 2005, what is the difference between the Debt(current US$) in Nigeria and Debt(current US$) in Sri Lanka?
Offer a very short reply. -1.36e+09. In the year 2006, what is the difference between the Debt(current US$) in Middle income and Debt(current US$) in Djibouti?
Your response must be concise. 1.64e+11. In the year 2006, what is the difference between the Debt(current US$) of Middle income and Debt(current US$) of Nigeria?
Your answer should be very brief. 1.63e+11. In the year 2006, what is the difference between the Debt(current US$) in Middle income and Debt(current US$) in Sri Lanka?
Your answer should be very brief. 1.61e+11. In the year 2006, what is the difference between the Debt(current US$) of Djibouti and Debt(current US$) of Nigeria?
Your response must be concise. -1.52e+09. In the year 2006, what is the difference between the Debt(current US$) in Djibouti and Debt(current US$) in Sri Lanka?
Your answer should be compact. -3.05e+09. In the year 2006, what is the difference between the Debt(current US$) in Nigeria and Debt(current US$) in Sri Lanka?
Provide a succinct answer. -1.54e+09. In the year 2007, what is the difference between the Debt(current US$) in Middle income and Debt(current US$) in Djibouti?
Your response must be concise. 1.76e+11. In the year 2007, what is the difference between the Debt(current US$) in Middle income and Debt(current US$) in Nigeria?
Your answer should be compact. 1.74e+11. In the year 2007, what is the difference between the Debt(current US$) in Middle income and Debt(current US$) in Sri Lanka?
Your answer should be compact. 1.73e+11. In the year 2007, what is the difference between the Debt(current US$) in Djibouti and Debt(current US$) in Nigeria?
Offer a very short reply. -1.91e+09. In the year 2007, what is the difference between the Debt(current US$) of Djibouti and Debt(current US$) of Sri Lanka?
Give a very brief answer. -3.68e+09. In the year 2007, what is the difference between the Debt(current US$) in Nigeria and Debt(current US$) in Sri Lanka?
Provide a succinct answer. -1.77e+09. In the year 2008, what is the difference between the Debt(current US$) in Middle income and Debt(current US$) in Djibouti?
Make the answer very short. 1.97e+11. In the year 2008, what is the difference between the Debt(current US$) in Middle income and Debt(current US$) in Nigeria?
Your answer should be very brief. 1.95e+11. In the year 2008, what is the difference between the Debt(current US$) in Middle income and Debt(current US$) in Sri Lanka?
Offer a terse response. 1.93e+11. In the year 2008, what is the difference between the Debt(current US$) in Djibouti and Debt(current US$) in Nigeria?
Provide a succinct answer. -2.48e+09. In the year 2008, what is the difference between the Debt(current US$) of Djibouti and Debt(current US$) of Sri Lanka?
Make the answer very short. -4.59e+09. In the year 2008, what is the difference between the Debt(current US$) of Nigeria and Debt(current US$) of Sri Lanka?
Provide a short and direct response. -2.11e+09. In the year 2009, what is the difference between the Debt(current US$) of Middle income and Debt(current US$) of Djibouti?
Offer a very short reply. 2.49e+11. In the year 2009, what is the difference between the Debt(current US$) in Middle income and Debt(current US$) in Nigeria?
Give a very brief answer. 2.45e+11. In the year 2009, what is the difference between the Debt(current US$) in Middle income and Debt(current US$) in Sri Lanka?
Your answer should be very brief. 2.43e+11. In the year 2009, what is the difference between the Debt(current US$) of Djibouti and Debt(current US$) of Nigeria?
Keep it short and to the point. -3.24e+09. In the year 2009, what is the difference between the Debt(current US$) in Djibouti and Debt(current US$) in Sri Lanka?
Ensure brevity in your answer.  -5.35e+09. In the year 2009, what is the difference between the Debt(current US$) in Nigeria and Debt(current US$) in Sri Lanka?
Offer a terse response. -2.11e+09. In the year 2010, what is the difference between the Debt(current US$) in Middle income and Debt(current US$) in Djibouti?
Provide a short and direct response. 2.62e+11. In the year 2010, what is the difference between the Debt(current US$) in Middle income and Debt(current US$) in Nigeria?
Your answer should be compact. 2.59e+11. In the year 2010, what is the difference between the Debt(current US$) in Middle income and Debt(current US$) in Sri Lanka?
Give a very brief answer. 2.56e+11. In the year 2010, what is the difference between the Debt(current US$) of Djibouti and Debt(current US$) of Nigeria?
Ensure brevity in your answer.  -3.66e+09. In the year 2010, what is the difference between the Debt(current US$) in Djibouti and Debt(current US$) in Sri Lanka?
Your response must be concise. -6.66e+09. In the year 2010, what is the difference between the Debt(current US$) of Nigeria and Debt(current US$) of Sri Lanka?
Make the answer very short. -3.00e+09. In the year 2011, what is the difference between the Debt(current US$) in Middle income and Debt(current US$) in Djibouti?
Your response must be concise. 2.91e+11. In the year 2011, what is the difference between the Debt(current US$) in Middle income and Debt(current US$) in Nigeria?
Your answer should be very brief. 2.88e+11. In the year 2011, what is the difference between the Debt(current US$) in Middle income and Debt(current US$) in Sri Lanka?
Your answer should be compact. 2.84e+11. In the year 2011, what is the difference between the Debt(current US$) in Djibouti and Debt(current US$) in Nigeria?
Your response must be concise. -3.11e+09. In the year 2011, what is the difference between the Debt(current US$) of Djibouti and Debt(current US$) of Sri Lanka?
Your answer should be very brief. -6.95e+09. In the year 2011, what is the difference between the Debt(current US$) of Nigeria and Debt(current US$) of Sri Lanka?
Keep it short and to the point. -3.84e+09. In the year 2012, what is the difference between the Debt(current US$) of Middle income and Debt(current US$) of Djibouti?
Your response must be concise. 3.46e+11. In the year 2012, what is the difference between the Debt(current US$) in Middle income and Debt(current US$) in Nigeria?
Make the answer very short. 3.43e+11. In the year 2012, what is the difference between the Debt(current US$) in Middle income and Debt(current US$) in Sri Lanka?
Provide a short and direct response. 3.39e+11. In the year 2012, what is the difference between the Debt(current US$) of Djibouti and Debt(current US$) of Nigeria?
Make the answer very short. -2.97e+09. In the year 2012, what is the difference between the Debt(current US$) in Djibouti and Debt(current US$) in Sri Lanka?
Your response must be concise. -6.77e+09. In the year 2012, what is the difference between the Debt(current US$) in Nigeria and Debt(current US$) in Sri Lanka?
Give a very brief answer. -3.80e+09. What is the ratio of the Debt(current US$) in Middle income in 2005 to that in 2006?
Keep it short and to the point. 1.01. What is the ratio of the Debt(current US$) in Djibouti in 2005 to that in 2006?
Provide a short and direct response. 1.03. What is the ratio of the Debt(current US$) of Nigeria in 2005 to that in 2006?
Offer a terse response. 1.02. What is the ratio of the Debt(current US$) in Sri Lanka in 2005 to that in 2006?
Your answer should be very brief. 0.96. What is the ratio of the Debt(current US$) of Middle income in 2005 to that in 2007?
Offer a very short reply. 0.94. What is the ratio of the Debt(current US$) in Djibouti in 2005 to that in 2007?
Offer a very short reply. 1.1. What is the ratio of the Debt(current US$) in Nigeria in 2005 to that in 2007?
Your answer should be compact. 0.84. What is the ratio of the Debt(current US$) of Sri Lanka in 2005 to that in 2007?
Provide a short and direct response. 0.81. What is the ratio of the Debt(current US$) of Middle income in 2005 to that in 2008?
Offer a terse response. 0.84. What is the ratio of the Debt(current US$) in Djibouti in 2005 to that in 2008?
Provide a succinct answer. 1.16. What is the ratio of the Debt(current US$) of Nigeria in 2005 to that in 2008?
Offer a terse response. 0.66. What is the ratio of the Debt(current US$) in Sri Lanka in 2005 to that in 2008?
Your answer should be compact. 0.66. What is the ratio of the Debt(current US$) of Middle income in 2005 to that in 2009?
Give a very brief answer. 0.67. What is the ratio of the Debt(current US$) in Djibouti in 2005 to that in 2009?
Your answer should be very brief. 1.45. What is the ratio of the Debt(current US$) in Nigeria in 2005 to that in 2009?
Your answer should be compact. 0.53. What is the ratio of the Debt(current US$) of Sri Lanka in 2005 to that in 2009?
Your answer should be very brief. 0.57. What is the ratio of the Debt(current US$) in Middle income in 2005 to that in 2010?
Your response must be concise. 0.63. What is the ratio of the Debt(current US$) in Djibouti in 2005 to that in 2010?
Your answer should be very brief. 1.32. What is the ratio of the Debt(current US$) of Nigeria in 2005 to that in 2010?
Ensure brevity in your answer.  0.47. What is the ratio of the Debt(current US$) of Sri Lanka in 2005 to that in 2010?
Provide a short and direct response. 0.46. What is the ratio of the Debt(current US$) of Middle income in 2005 to that in 2011?
Offer a very short reply. 0.57. What is the ratio of the Debt(current US$) in Djibouti in 2005 to that in 2011?
Make the answer very short. 1.39. What is the ratio of the Debt(current US$) in Nigeria in 2005 to that in 2011?
Provide a succinct answer. 0.54. What is the ratio of the Debt(current US$) in Sri Lanka in 2005 to that in 2011?
Offer a terse response. 0.44. What is the ratio of the Debt(current US$) of Middle income in 2005 to that in 2012?
Give a very brief answer. 0.48. What is the ratio of the Debt(current US$) in Djibouti in 2005 to that in 2012?
Your answer should be compact. 0.85. What is the ratio of the Debt(current US$) of Nigeria in 2005 to that in 2012?
Keep it short and to the point. 0.55. What is the ratio of the Debt(current US$) of Sri Lanka in 2005 to that in 2012?
Offer a very short reply. 0.45. What is the ratio of the Debt(current US$) of Middle income in 2006 to that in 2007?
Provide a succinct answer. 0.93. What is the ratio of the Debt(current US$) of Djibouti in 2006 to that in 2007?
Give a very brief answer. 1.06. What is the ratio of the Debt(current US$) in Nigeria in 2006 to that in 2007?
Provide a succinct answer. 0.82. What is the ratio of the Debt(current US$) of Sri Lanka in 2006 to that in 2007?
Ensure brevity in your answer.  0.84. What is the ratio of the Debt(current US$) of Middle income in 2006 to that in 2008?
Offer a very short reply. 0.83. What is the ratio of the Debt(current US$) of Djibouti in 2006 to that in 2008?
Make the answer very short. 1.12. What is the ratio of the Debt(current US$) in Nigeria in 2006 to that in 2008?
Make the answer very short. 0.65. What is the ratio of the Debt(current US$) of Sri Lanka in 2006 to that in 2008?
Your response must be concise. 0.68. What is the ratio of the Debt(current US$) of Middle income in 2006 to that in 2009?
Your answer should be very brief. 0.66. What is the ratio of the Debt(current US$) of Djibouti in 2006 to that in 2009?
Give a very brief answer. 1.4. What is the ratio of the Debt(current US$) in Nigeria in 2006 to that in 2009?
Your answer should be very brief. 0.51. What is the ratio of the Debt(current US$) in Sri Lanka in 2006 to that in 2009?
Make the answer very short. 0.6. What is the ratio of the Debt(current US$) in Middle income in 2006 to that in 2010?
Keep it short and to the point. 0.63. What is the ratio of the Debt(current US$) of Djibouti in 2006 to that in 2010?
Give a very brief answer. 1.28. What is the ratio of the Debt(current US$) in Nigeria in 2006 to that in 2010?
Give a very brief answer. 0.46. What is the ratio of the Debt(current US$) in Sri Lanka in 2006 to that in 2010?
Your response must be concise. 0.48. What is the ratio of the Debt(current US$) in Middle income in 2006 to that in 2011?
Offer a very short reply. 0.56. What is the ratio of the Debt(current US$) of Djibouti in 2006 to that in 2011?
Offer a very short reply. 1.35. What is the ratio of the Debt(current US$) in Nigeria in 2006 to that in 2011?
Ensure brevity in your answer.  0.53. What is the ratio of the Debt(current US$) in Sri Lanka in 2006 to that in 2011?
Make the answer very short. 0.46. What is the ratio of the Debt(current US$) of Middle income in 2006 to that in 2012?
Provide a short and direct response. 0.47. What is the ratio of the Debt(current US$) of Djibouti in 2006 to that in 2012?
Your answer should be very brief. 0.82. What is the ratio of the Debt(current US$) of Nigeria in 2006 to that in 2012?
Make the answer very short. 0.54. What is the ratio of the Debt(current US$) in Sri Lanka in 2006 to that in 2012?
Your answer should be very brief. 0.47. What is the ratio of the Debt(current US$) in Middle income in 2007 to that in 2008?
Offer a terse response. 0.89. What is the ratio of the Debt(current US$) in Djibouti in 2007 to that in 2008?
Make the answer very short. 1.06. What is the ratio of the Debt(current US$) of Nigeria in 2007 to that in 2008?
Keep it short and to the point. 0.79. What is the ratio of the Debt(current US$) of Sri Lanka in 2007 to that in 2008?
Your answer should be very brief. 0.81. What is the ratio of the Debt(current US$) in Middle income in 2007 to that in 2009?
Your answer should be compact. 0.71. What is the ratio of the Debt(current US$) of Djibouti in 2007 to that in 2009?
Offer a very short reply. 1.32. What is the ratio of the Debt(current US$) of Nigeria in 2007 to that in 2009?
Give a very brief answer. 0.63. What is the ratio of the Debt(current US$) of Sri Lanka in 2007 to that in 2009?
Ensure brevity in your answer.  0.71. What is the ratio of the Debt(current US$) in Middle income in 2007 to that in 2010?
Your response must be concise. 0.67. What is the ratio of the Debt(current US$) in Djibouti in 2007 to that in 2010?
Offer a very short reply. 1.2. What is the ratio of the Debt(current US$) in Nigeria in 2007 to that in 2010?
Provide a succinct answer. 0.55. What is the ratio of the Debt(current US$) in Sri Lanka in 2007 to that in 2010?
Offer a terse response. 0.57. What is the ratio of the Debt(current US$) of Middle income in 2007 to that in 2011?
Provide a succinct answer. 0.61. What is the ratio of the Debt(current US$) of Djibouti in 2007 to that in 2011?
Your answer should be very brief. 1.27. What is the ratio of the Debt(current US$) of Nigeria in 2007 to that in 2011?
Offer a very short reply. 0.65. What is the ratio of the Debt(current US$) of Sri Lanka in 2007 to that in 2011?
Offer a very short reply. 0.55. What is the ratio of the Debt(current US$) in Middle income in 2007 to that in 2012?
Make the answer very short. 0.51. What is the ratio of the Debt(current US$) of Djibouti in 2007 to that in 2012?
Ensure brevity in your answer.  0.77. What is the ratio of the Debt(current US$) in Nigeria in 2007 to that in 2012?
Ensure brevity in your answer.  0.65. What is the ratio of the Debt(current US$) in Sri Lanka in 2007 to that in 2012?
Provide a short and direct response. 0.55. What is the ratio of the Debt(current US$) in Middle income in 2008 to that in 2009?
Offer a terse response. 0.79. What is the ratio of the Debt(current US$) of Djibouti in 2008 to that in 2009?
Make the answer very short. 1.25. What is the ratio of the Debt(current US$) in Nigeria in 2008 to that in 2009?
Offer a terse response. 0.79. What is the ratio of the Debt(current US$) of Sri Lanka in 2008 to that in 2009?
Provide a short and direct response. 0.87. What is the ratio of the Debt(current US$) of Middle income in 2008 to that in 2010?
Make the answer very short. 0.75. What is the ratio of the Debt(current US$) of Djibouti in 2008 to that in 2010?
Make the answer very short. 1.14. What is the ratio of the Debt(current US$) of Nigeria in 2008 to that in 2010?
Your answer should be compact. 0.7. What is the ratio of the Debt(current US$) of Sri Lanka in 2008 to that in 2010?
Make the answer very short. 0.7. What is the ratio of the Debt(current US$) in Middle income in 2008 to that in 2011?
Your response must be concise. 0.68. What is the ratio of the Debt(current US$) in Djibouti in 2008 to that in 2011?
Your response must be concise. 1.2. What is the ratio of the Debt(current US$) of Nigeria in 2008 to that in 2011?
Ensure brevity in your answer.  0.82. What is the ratio of the Debt(current US$) in Sri Lanka in 2008 to that in 2011?
Your response must be concise. 0.67. What is the ratio of the Debt(current US$) of Middle income in 2008 to that in 2012?
Your answer should be compact. 0.57. What is the ratio of the Debt(current US$) in Djibouti in 2008 to that in 2012?
Offer a very short reply. 0.73. What is the ratio of the Debt(current US$) of Nigeria in 2008 to that in 2012?
Give a very brief answer. 0.83. What is the ratio of the Debt(current US$) of Sri Lanka in 2008 to that in 2012?
Provide a succinct answer. 0.68. What is the ratio of the Debt(current US$) of Middle income in 2009 to that in 2010?
Offer a terse response. 0.95. What is the ratio of the Debt(current US$) of Djibouti in 2009 to that in 2010?
Make the answer very short. 0.91. What is the ratio of the Debt(current US$) of Nigeria in 2009 to that in 2010?
Ensure brevity in your answer.  0.89. What is the ratio of the Debt(current US$) of Sri Lanka in 2009 to that in 2010?
Offer a very short reply. 0.81. What is the ratio of the Debt(current US$) of Middle income in 2009 to that in 2011?
Keep it short and to the point. 0.85. What is the ratio of the Debt(current US$) in Djibouti in 2009 to that in 2011?
Offer a very short reply. 0.96. What is the ratio of the Debt(current US$) in Nigeria in 2009 to that in 2011?
Your answer should be very brief. 1.04. What is the ratio of the Debt(current US$) of Sri Lanka in 2009 to that in 2011?
Offer a terse response. 0.77. What is the ratio of the Debt(current US$) in Middle income in 2009 to that in 2012?
Your answer should be compact. 0.72. What is the ratio of the Debt(current US$) of Djibouti in 2009 to that in 2012?
Offer a terse response. 0.58. What is the ratio of the Debt(current US$) in Nigeria in 2009 to that in 2012?
Ensure brevity in your answer.  1.04. What is the ratio of the Debt(current US$) of Sri Lanka in 2009 to that in 2012?
Your answer should be compact. 0.78. What is the ratio of the Debt(current US$) in Middle income in 2010 to that in 2011?
Your response must be concise. 0.9. What is the ratio of the Debt(current US$) of Djibouti in 2010 to that in 2011?
Make the answer very short. 1.05. What is the ratio of the Debt(current US$) in Nigeria in 2010 to that in 2011?
Offer a terse response. 1.17. What is the ratio of the Debt(current US$) in Sri Lanka in 2010 to that in 2011?
Ensure brevity in your answer.  0.96. What is the ratio of the Debt(current US$) of Middle income in 2010 to that in 2012?
Offer a very short reply. 0.76. What is the ratio of the Debt(current US$) in Djibouti in 2010 to that in 2012?
Offer a very short reply. 0.64. What is the ratio of the Debt(current US$) of Nigeria in 2010 to that in 2012?
Give a very brief answer. 1.18. What is the ratio of the Debt(current US$) of Sri Lanka in 2010 to that in 2012?
Provide a succinct answer. 0.97. What is the ratio of the Debt(current US$) in Middle income in 2011 to that in 2012?
Your response must be concise. 0.84. What is the ratio of the Debt(current US$) of Djibouti in 2011 to that in 2012?
Your response must be concise. 0.61. What is the ratio of the Debt(current US$) in Nigeria in 2011 to that in 2012?
Make the answer very short. 1.01. What is the ratio of the Debt(current US$) of Sri Lanka in 2011 to that in 2012?
Ensure brevity in your answer.  1.01. What is the difference between the highest and the second highest Debt(current US$) of Middle income?
Ensure brevity in your answer.  5.46e+1. What is the difference between the highest and the second highest Debt(current US$) in Djibouti?
Provide a short and direct response. 4.38e+07. What is the difference between the highest and the second highest Debt(current US$) of Nigeria?
Offer a terse response. 4.40e+08. What is the difference between the highest and the second highest Debt(current US$) of Sri Lanka?
Make the answer very short. 6.60e+07. What is the difference between the highest and the lowest Debt(current US$) of Middle income?
Provide a succinct answer. 1.82e+11. What is the difference between the highest and the lowest Debt(current US$) of Djibouti?
Ensure brevity in your answer.  1.19e+08. What is the difference between the highest and the lowest Debt(current US$) of Nigeria?
Provide a succinct answer. 2.09e+09. What is the difference between the highest and the lowest Debt(current US$) of Sri Lanka?
Your answer should be very brief. 3.98e+09. 